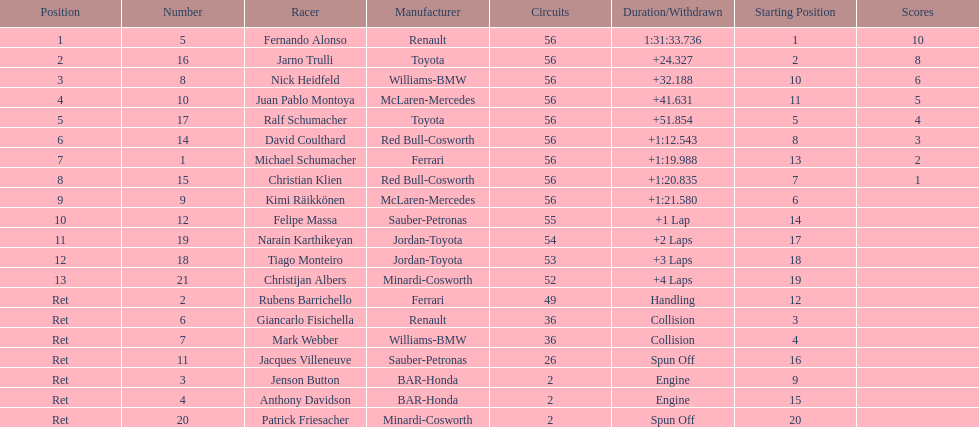Who was the last driver from the uk to actually finish the 56 laps? David Coulthard. Write the full table. {'header': ['Position', 'Number', 'Racer', 'Manufacturer', 'Circuits', 'Duration/Withdrawn', 'Starting Position', 'Scores'], 'rows': [['1', '5', 'Fernando Alonso', 'Renault', '56', '1:31:33.736', '1', '10'], ['2', '16', 'Jarno Trulli', 'Toyota', '56', '+24.327', '2', '8'], ['3', '8', 'Nick Heidfeld', 'Williams-BMW', '56', '+32.188', '10', '6'], ['4', '10', 'Juan Pablo Montoya', 'McLaren-Mercedes', '56', '+41.631', '11', '5'], ['5', '17', 'Ralf Schumacher', 'Toyota', '56', '+51.854', '5', '4'], ['6', '14', 'David Coulthard', 'Red Bull-Cosworth', '56', '+1:12.543', '8', '3'], ['7', '1', 'Michael Schumacher', 'Ferrari', '56', '+1:19.988', '13', '2'], ['8', '15', 'Christian Klien', 'Red Bull-Cosworth', '56', '+1:20.835', '7', '1'], ['9', '9', 'Kimi Räikkönen', 'McLaren-Mercedes', '56', '+1:21.580', '6', ''], ['10', '12', 'Felipe Massa', 'Sauber-Petronas', '55', '+1 Lap', '14', ''], ['11', '19', 'Narain Karthikeyan', 'Jordan-Toyota', '54', '+2 Laps', '17', ''], ['12', '18', 'Tiago Monteiro', 'Jordan-Toyota', '53', '+3 Laps', '18', ''], ['13', '21', 'Christijan Albers', 'Minardi-Cosworth', '52', '+4 Laps', '19', ''], ['Ret', '2', 'Rubens Barrichello', 'Ferrari', '49', 'Handling', '12', ''], ['Ret', '6', 'Giancarlo Fisichella', 'Renault', '36', 'Collision', '3', ''], ['Ret', '7', 'Mark Webber', 'Williams-BMW', '36', 'Collision', '4', ''], ['Ret', '11', 'Jacques Villeneuve', 'Sauber-Petronas', '26', 'Spun Off', '16', ''], ['Ret', '3', 'Jenson Button', 'BAR-Honda', '2', 'Engine', '9', ''], ['Ret', '4', 'Anthony Davidson', 'BAR-Honda', '2', 'Engine', '15', ''], ['Ret', '20', 'Patrick Friesacher', 'Minardi-Cosworth', '2', 'Spun Off', '20', '']]} 